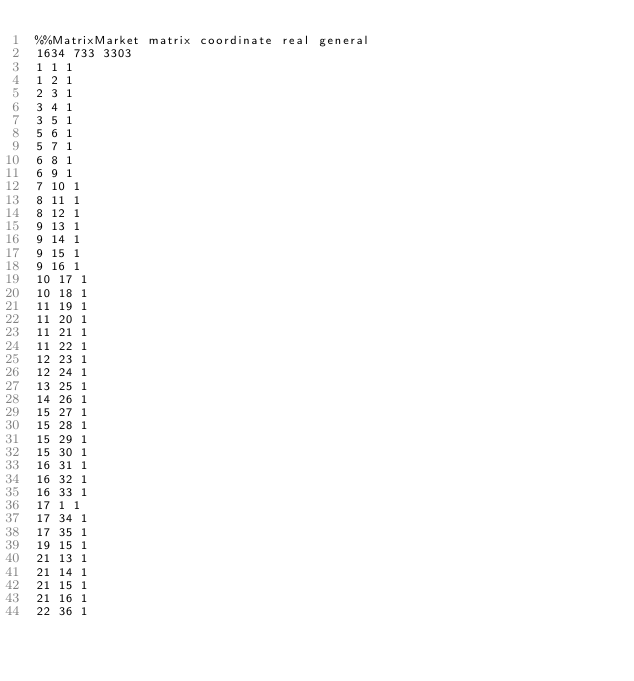<code> <loc_0><loc_0><loc_500><loc_500><_ObjectiveC_>%%MatrixMarket matrix coordinate real general
1634 733 3303                                     
1 1 1
1 2 1
2 3 1
3 4 1
3 5 1
5 6 1
5 7 1
6 8 1
6 9 1
7 10 1
8 11 1
8 12 1
9 13 1
9 14 1
9 15 1
9 16 1
10 17 1
10 18 1
11 19 1
11 20 1
11 21 1
11 22 1
12 23 1
12 24 1
13 25 1
14 26 1
15 27 1
15 28 1
15 29 1
15 30 1
16 31 1
16 32 1
16 33 1
17 1 1
17 34 1
17 35 1
19 15 1
21 13 1
21 14 1
21 15 1
21 16 1
22 36 1</code> 